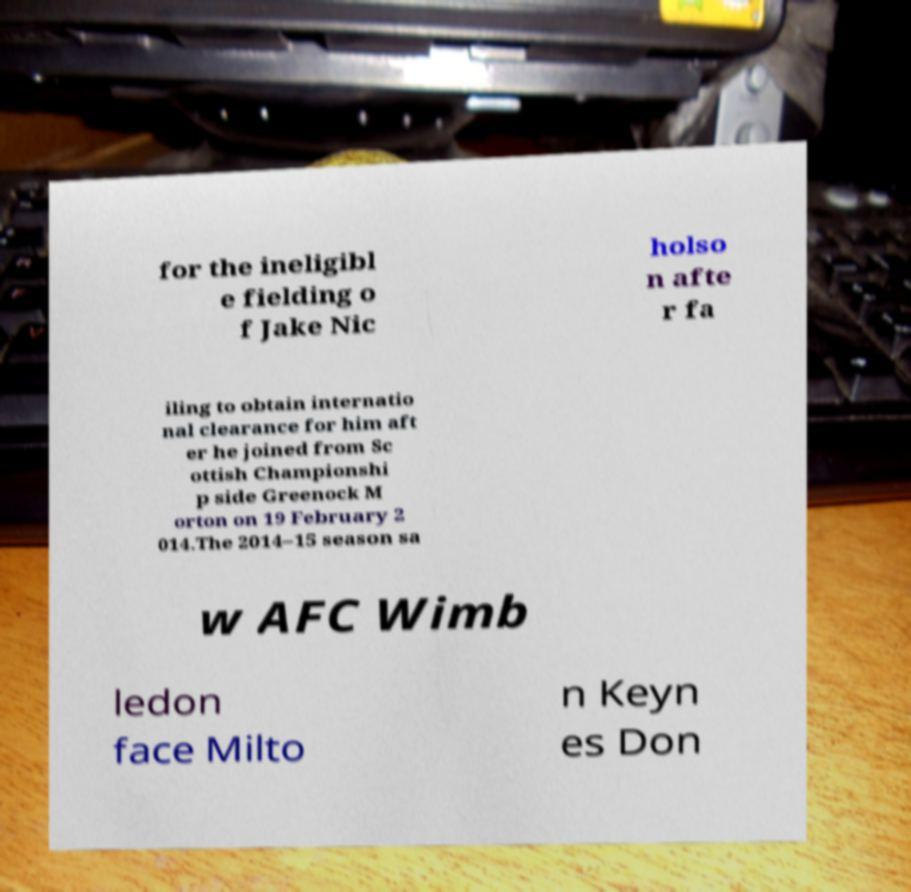For documentation purposes, I need the text within this image transcribed. Could you provide that? for the ineligibl e fielding o f Jake Nic holso n afte r fa iling to obtain internatio nal clearance for him aft er he joined from Sc ottish Championshi p side Greenock M orton on 19 February 2 014.The 2014–15 season sa w AFC Wimb ledon face Milto n Keyn es Don 